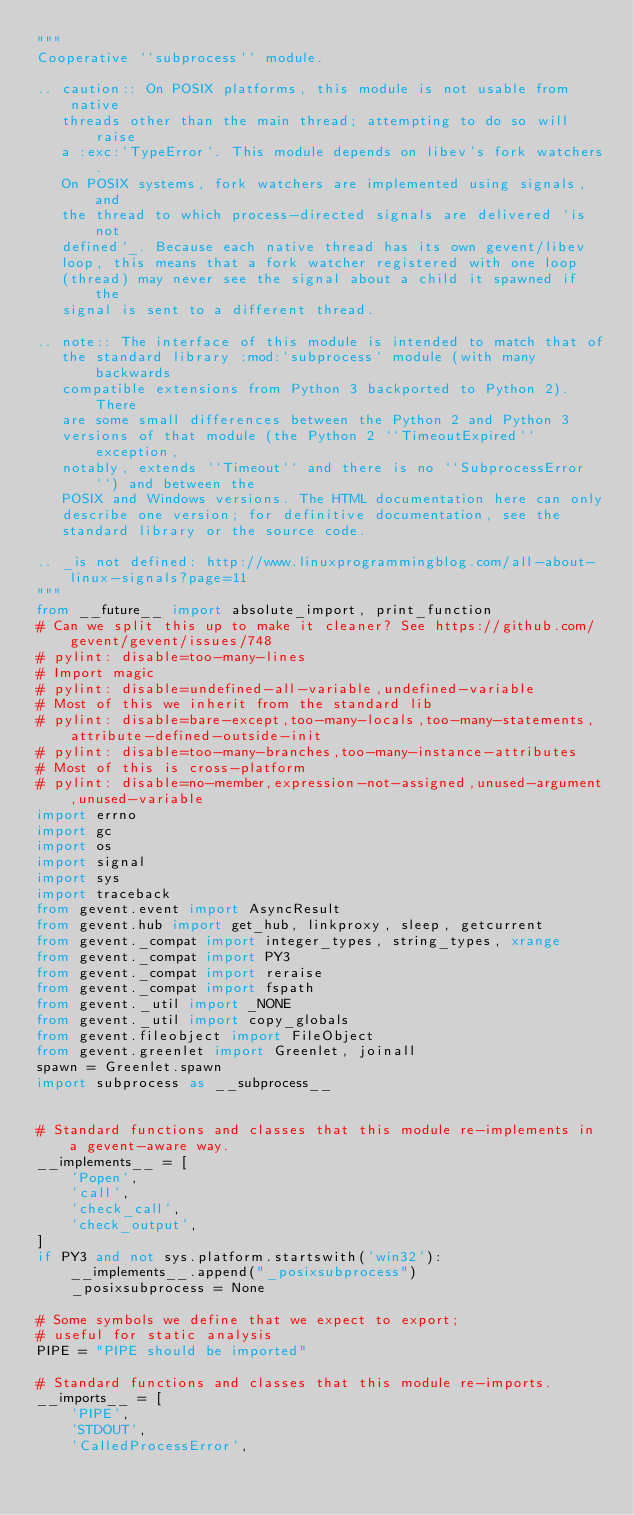<code> <loc_0><loc_0><loc_500><loc_500><_Python_>"""
Cooperative ``subprocess`` module.

.. caution:: On POSIX platforms, this module is not usable from native
   threads other than the main thread; attempting to do so will raise
   a :exc:`TypeError`. This module depends on libev's fork watchers.
   On POSIX systems, fork watchers are implemented using signals, and
   the thread to which process-directed signals are delivered `is not
   defined`_. Because each native thread has its own gevent/libev
   loop, this means that a fork watcher registered with one loop
   (thread) may never see the signal about a child it spawned if the
   signal is sent to a different thread.

.. note:: The interface of this module is intended to match that of
   the standard library :mod:`subprocess` module (with many backwards
   compatible extensions from Python 3 backported to Python 2). There
   are some small differences between the Python 2 and Python 3
   versions of that module (the Python 2 ``TimeoutExpired`` exception,
   notably, extends ``Timeout`` and there is no ``SubprocessError``) and between the
   POSIX and Windows versions. The HTML documentation here can only
   describe one version; for definitive documentation, see the
   standard library or the source code.

.. _is not defined: http://www.linuxprogrammingblog.com/all-about-linux-signals?page=11
"""
from __future__ import absolute_import, print_function
# Can we split this up to make it cleaner? See https://github.com/gevent/gevent/issues/748
# pylint: disable=too-many-lines
# Import magic
# pylint: disable=undefined-all-variable,undefined-variable
# Most of this we inherit from the standard lib
# pylint: disable=bare-except,too-many-locals,too-many-statements,attribute-defined-outside-init
# pylint: disable=too-many-branches,too-many-instance-attributes
# Most of this is cross-platform
# pylint: disable=no-member,expression-not-assigned,unused-argument,unused-variable
import errno
import gc
import os
import signal
import sys
import traceback
from gevent.event import AsyncResult
from gevent.hub import get_hub, linkproxy, sleep, getcurrent
from gevent._compat import integer_types, string_types, xrange
from gevent._compat import PY3
from gevent._compat import reraise
from gevent._compat import fspath
from gevent._util import _NONE
from gevent._util import copy_globals
from gevent.fileobject import FileObject
from gevent.greenlet import Greenlet, joinall
spawn = Greenlet.spawn
import subprocess as __subprocess__


# Standard functions and classes that this module re-implements in a gevent-aware way.
__implements__ = [
    'Popen',
    'call',
    'check_call',
    'check_output',
]
if PY3 and not sys.platform.startswith('win32'):
    __implements__.append("_posixsubprocess")
    _posixsubprocess = None

# Some symbols we define that we expect to export;
# useful for static analysis
PIPE = "PIPE should be imported"

# Standard functions and classes that this module re-imports.
__imports__ = [
    'PIPE',
    'STDOUT',
    'CalledProcessError',</code> 